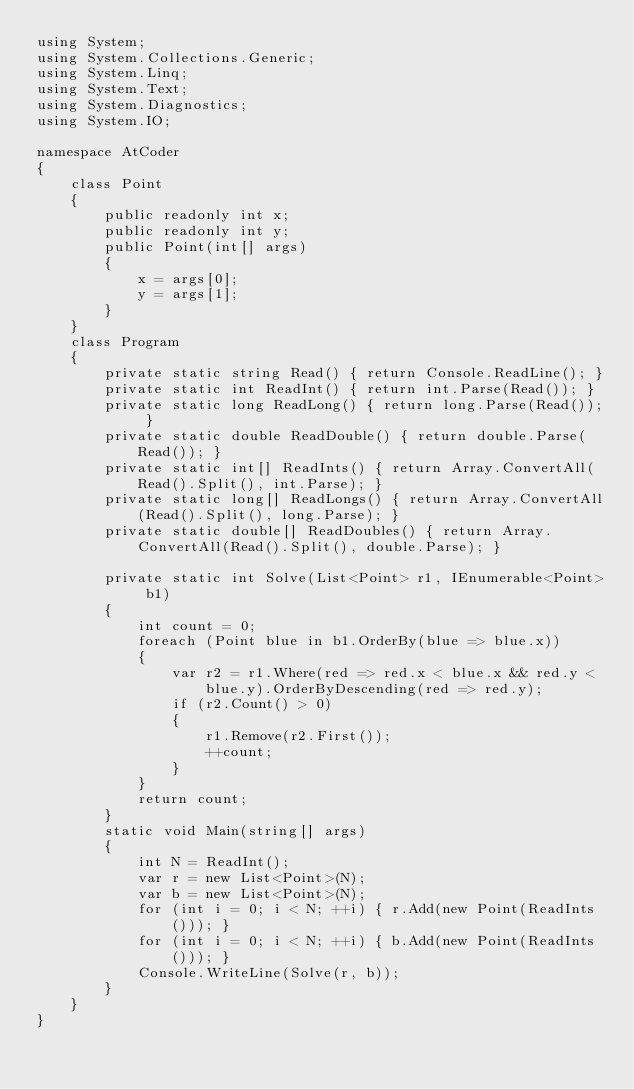Convert code to text. <code><loc_0><loc_0><loc_500><loc_500><_C#_>using System;
using System.Collections.Generic;
using System.Linq;
using System.Text;
using System.Diagnostics;
using System.IO;

namespace AtCoder
{
    class Point
    {
        public readonly int x;
        public readonly int y;
        public Point(int[] args)
        {
            x = args[0];
            y = args[1];
        }
    }
    class Program
    {
        private static string Read() { return Console.ReadLine(); }
        private static int ReadInt() { return int.Parse(Read()); }
        private static long ReadLong() { return long.Parse(Read()); }
        private static double ReadDouble() { return double.Parse(Read()); }
        private static int[] ReadInts() { return Array.ConvertAll(Read().Split(), int.Parse); }
        private static long[] ReadLongs() { return Array.ConvertAll(Read().Split(), long.Parse); }
        private static double[] ReadDoubles() { return Array.ConvertAll(Read().Split(), double.Parse); }

        private static int Solve(List<Point> r1, IEnumerable<Point> b1)
        {
            int count = 0;
            foreach (Point blue in b1.OrderBy(blue => blue.x))
            {
                var r2 = r1.Where(red => red.x < blue.x && red.y < blue.y).OrderByDescending(red => red.y);
                if (r2.Count() > 0)
                {
                    r1.Remove(r2.First());
                    ++count;
                }
            }
            return count;
        }
        static void Main(string[] args)
        {
            int N = ReadInt();
            var r = new List<Point>(N);
            var b = new List<Point>(N);
            for (int i = 0; i < N; ++i) { r.Add(new Point(ReadInts())); }
            for (int i = 0; i < N; ++i) { b.Add(new Point(ReadInts())); }
            Console.WriteLine(Solve(r, b));
        }
    }
}
</code> 